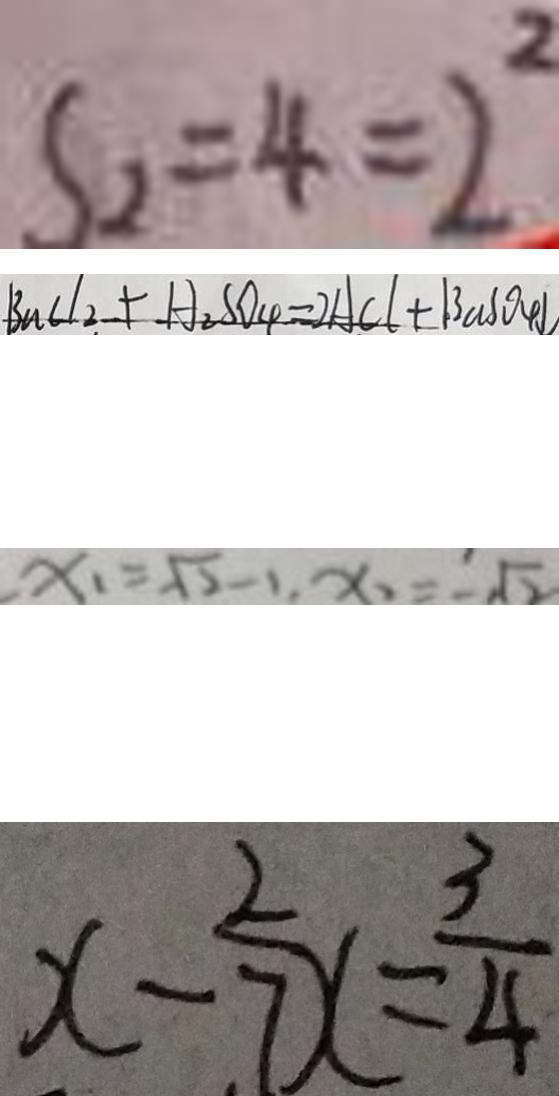Convert formula to latex. <formula><loc_0><loc_0><loc_500><loc_500>S _ { 2 } = 4 = 2 ^ { 2 } 
 B n C l _ { 2 } + H _ { 2 } S O _ { 4 } = 2 A C l + B a S O _ { 4 } \downarrow 
 x _ { 1 } = \sqrt { 2 } - 1 , x _ { 2 } = - \sqrt { 2 } 
 x - \frac { 2 } { 7 } x = \frac { 3 } { 4 }</formula> 